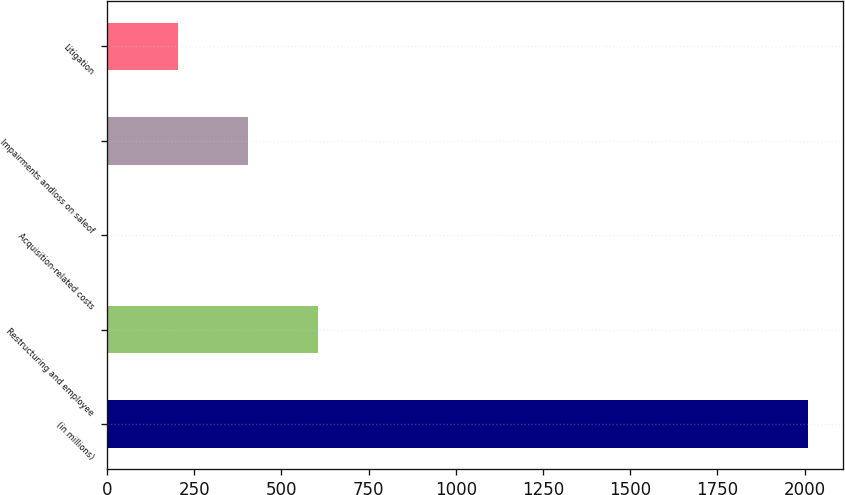Convert chart. <chart><loc_0><loc_0><loc_500><loc_500><bar_chart><fcel>(in millions)<fcel>Restructuring and employee<fcel>Acquisition-related costs<fcel>Impairments andloss on saleof<fcel>Litigation<nl><fcel>2009<fcel>604.66<fcel>2.8<fcel>404.04<fcel>203.42<nl></chart> 